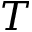Convert formula to latex. <formula><loc_0><loc_0><loc_500><loc_500>T</formula> 